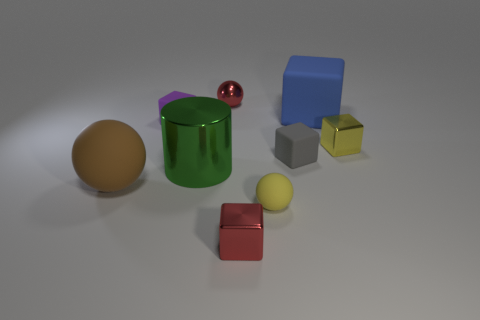There is another large object that is the same shape as the gray thing; what is its color?
Offer a very short reply. Blue. Do the blue cube and the red shiny sphere have the same size?
Your response must be concise. No. The gray block has what size?
Offer a very short reply. Small. What is the material of the yellow thing that is in front of the yellow metallic thing?
Your answer should be very brief. Rubber. Are the tiny sphere that is in front of the tiny purple matte object and the tiny gray block made of the same material?
Provide a short and direct response. Yes. What is the shape of the green object?
Keep it short and to the point. Cylinder. There is a ball to the right of the red shiny thing behind the tiny gray matte cube; what number of large objects are left of it?
Your answer should be compact. 2. What number of other objects are the same material as the green cylinder?
Ensure brevity in your answer.  3. What material is the gray block that is the same size as the yellow rubber thing?
Offer a terse response. Rubber. Is the color of the tiny metallic cube that is on the left side of the blue block the same as the sphere that is behind the green cylinder?
Your answer should be compact. Yes. 